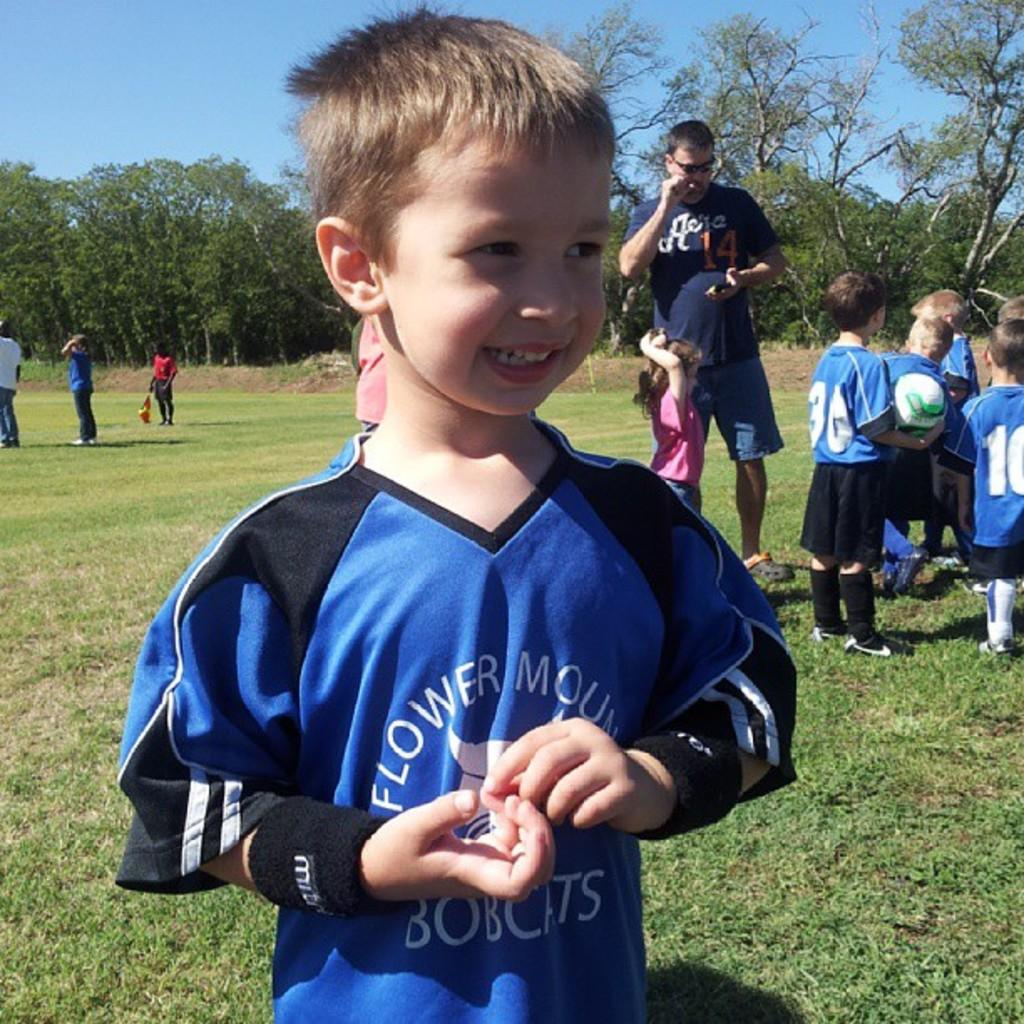<image>
Offer a succinct explanation of the picture presented. A small boy waits to play football in the park wearing a Flower Mount Bobcats jersey. 